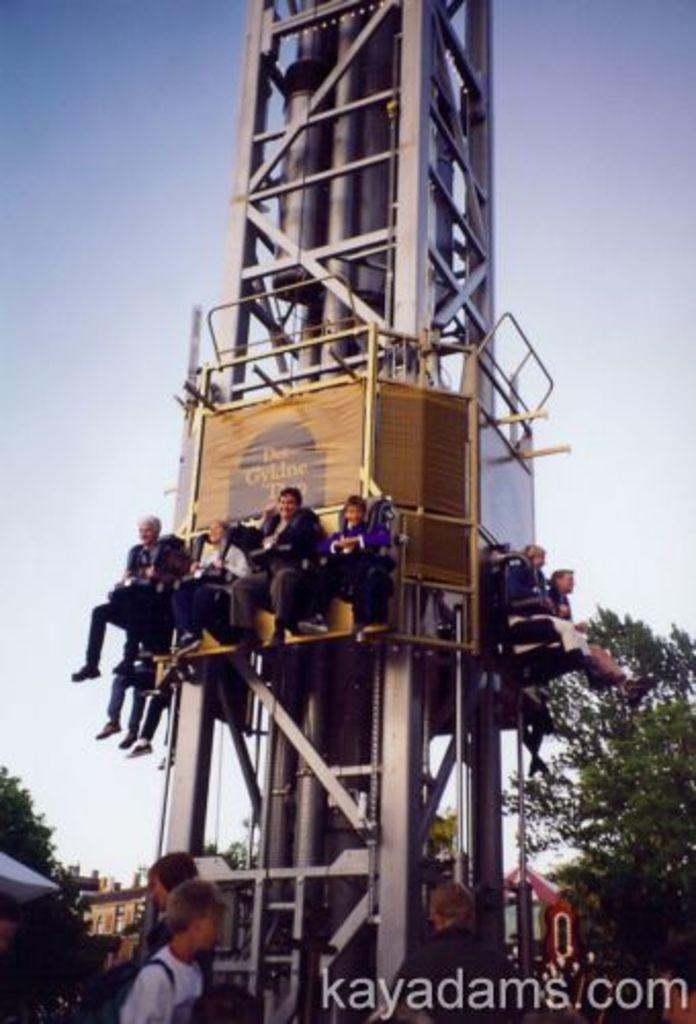Please provide a concise description of this image. In this picture I can see group of people standing, there are trees, there are group of people riding a drop tower, and in the background there is sky and there is a watermark on the image. 